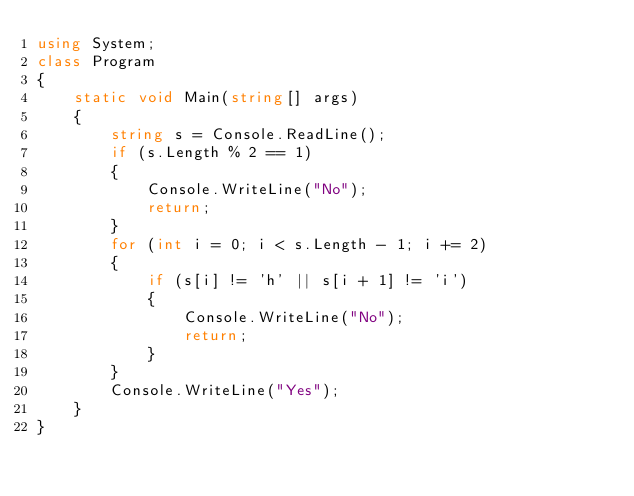<code> <loc_0><loc_0><loc_500><loc_500><_C#_>using System;
class Program
{
    static void Main(string[] args)
    {
        string s = Console.ReadLine();
        if (s.Length % 2 == 1)
        {
            Console.WriteLine("No");
            return;
        }
        for (int i = 0; i < s.Length - 1; i += 2)
        {
            if (s[i] != 'h' || s[i + 1] != 'i')
            {
                Console.WriteLine("No");
                return;
            }
        }
        Console.WriteLine("Yes");
    }
}</code> 